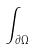<formula> <loc_0><loc_0><loc_500><loc_500>\int _ { \partial \Omega }</formula> 